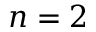<formula> <loc_0><loc_0><loc_500><loc_500>n = 2</formula> 